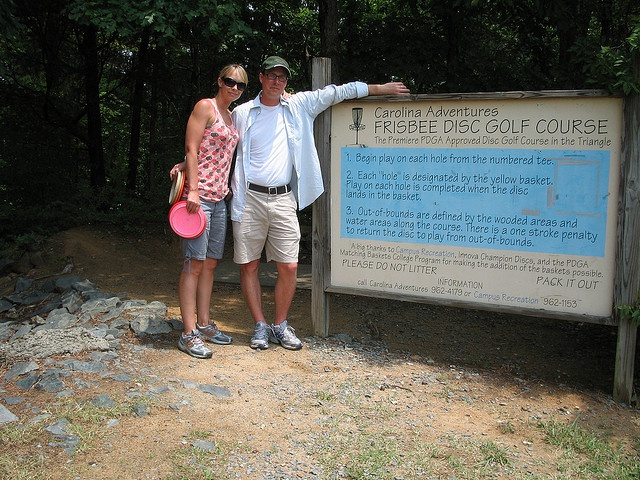Describe the objects in this image and their specific colors. I can see people in black, lavender, darkgray, and gray tones, people in black, brown, gray, lightpink, and maroon tones, and frisbee in black, salmon, lightpink, and brown tones in this image. 